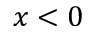Convert formula to latex. <formula><loc_0><loc_0><loc_500><loc_500>x < 0</formula> 